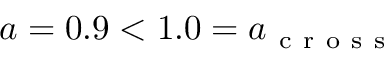Convert formula to latex. <formula><loc_0><loc_0><loc_500><loc_500>a = 0 . 9 < 1 . 0 = a _ { c r o s s }</formula> 